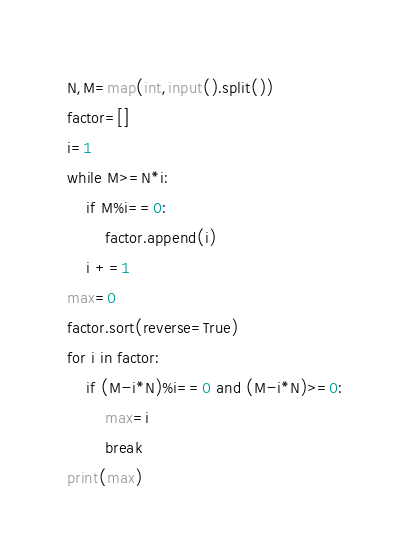<code> <loc_0><loc_0><loc_500><loc_500><_Python_>N,M=map(int,input().split())
factor=[]
i=1
while M>=N*i:
    if M%i==0:
        factor.append(i)
    i +=1
max=0
factor.sort(reverse=True)
for i in factor:
    if (M-i*N)%i==0 and (M-i*N)>=0:
        max=i
        break
print(max)</code> 